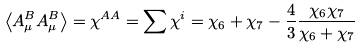<formula> <loc_0><loc_0><loc_500><loc_500>\left \langle A ^ { B } _ { \mu } A ^ { B } _ { \mu } \right \rangle = \chi ^ { A A } = \sum \chi ^ { i } = \chi _ { 6 } + \chi _ { 7 } - \frac { 4 } { 3 } \frac { \chi _ { 6 } \chi _ { 7 } } { \chi _ { 6 } + \chi _ { 7 } }</formula> 